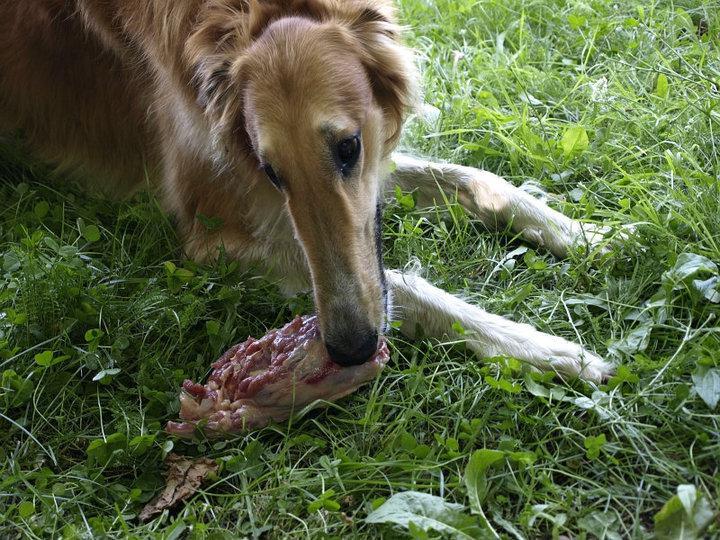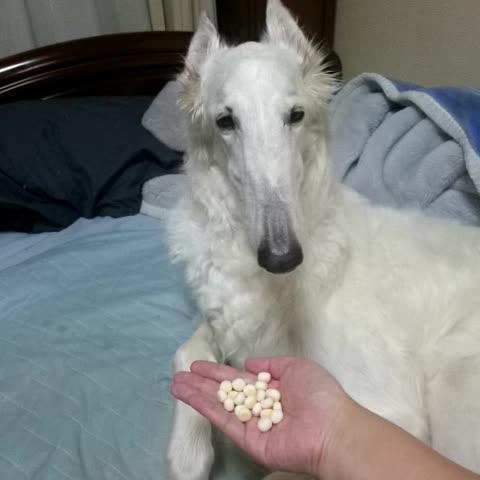The first image is the image on the left, the second image is the image on the right. For the images displayed, is the sentence "One image shows a dog being hand fed." factually correct? Answer yes or no. Yes. 